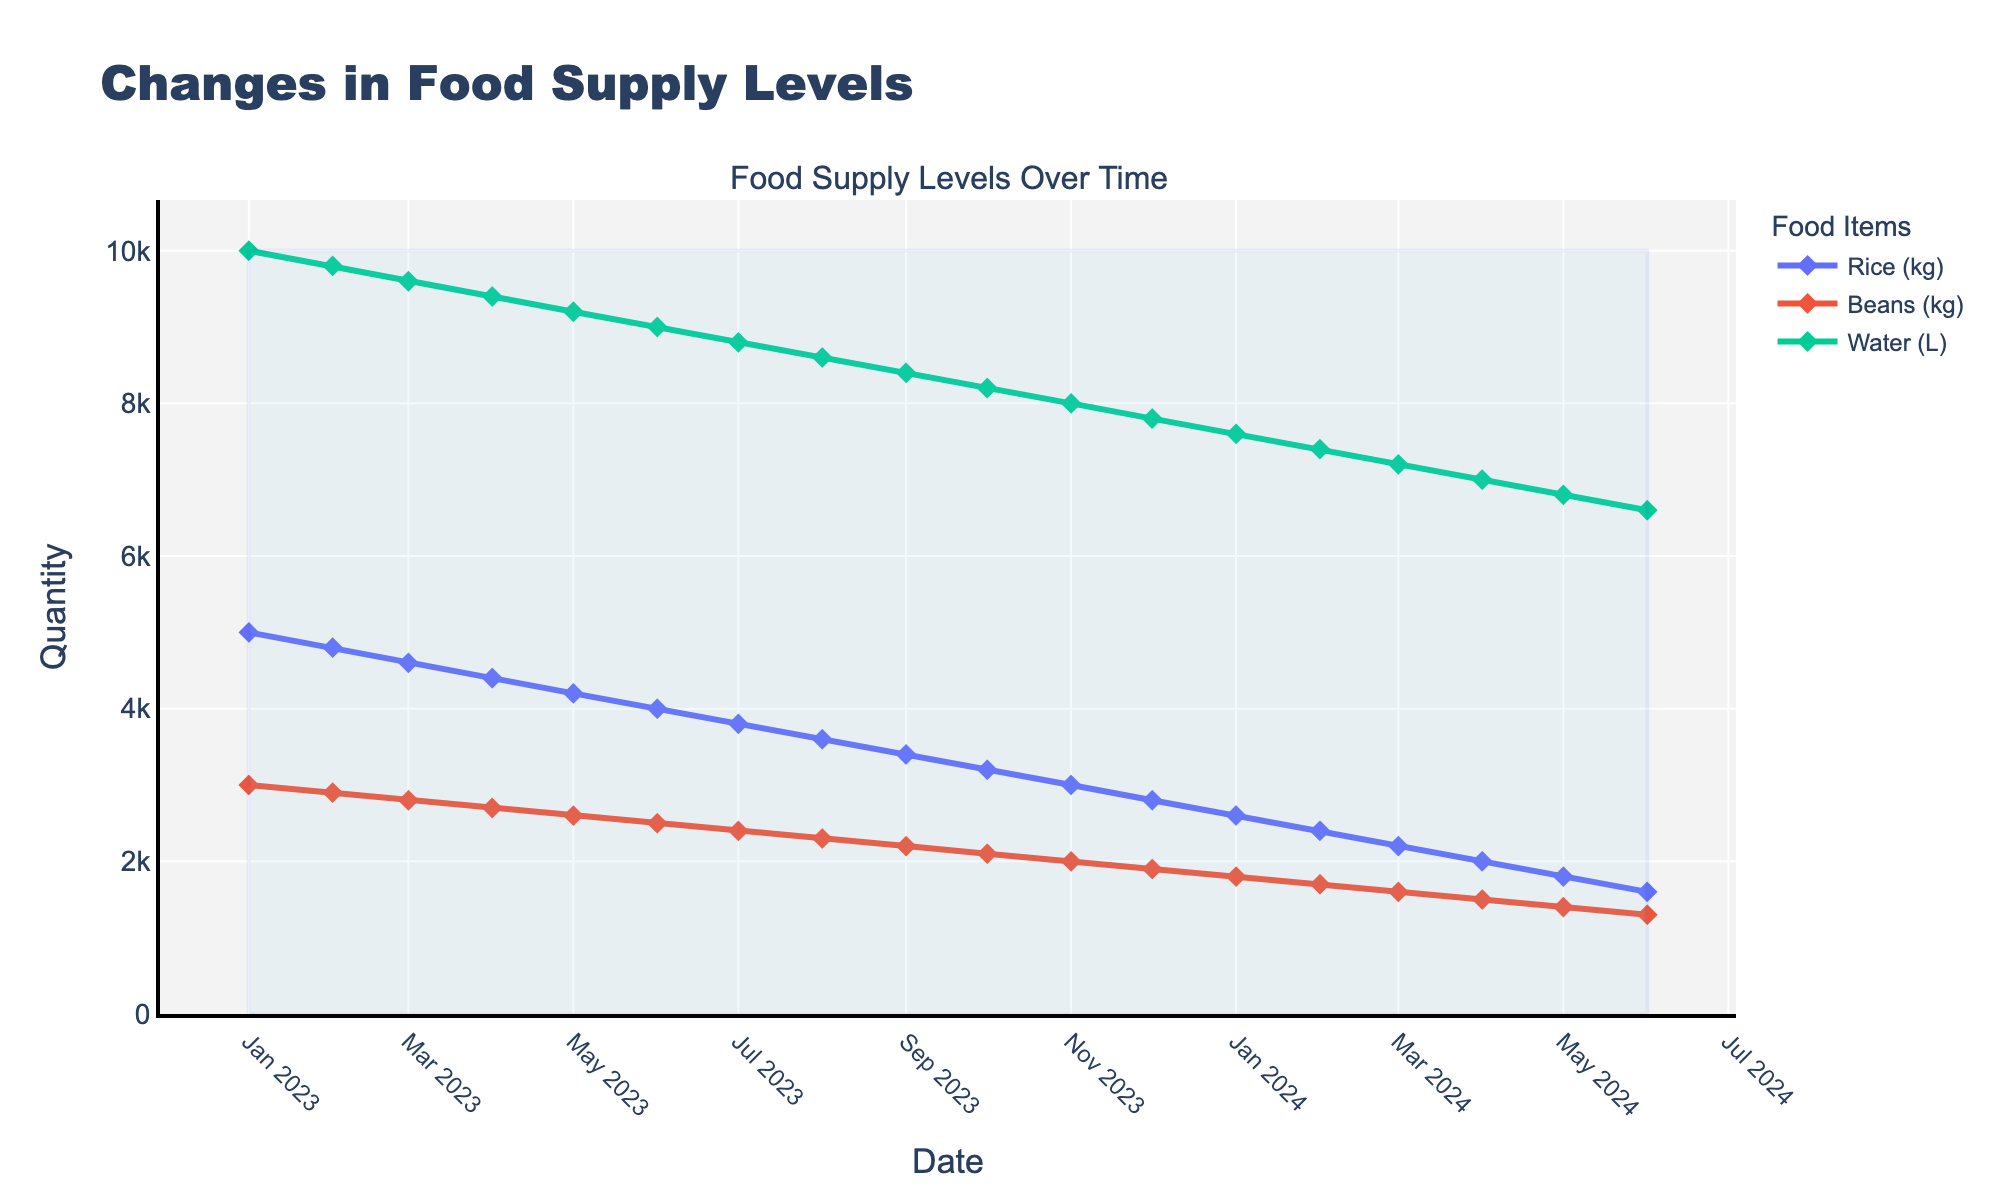what's the overall trend in the rice supply levels from January 2023 to June 2024? The rice supply levels decrease steadily over time. By observing the line representing rice, we see a consistent downward slope from the start to the end of the given timeframe.
Answer: Decreasing trend Which food item had the steepest decline from January 2023 to June 2024? By comparing the slopes of the lines, the line representing rice shows the steepest decline, indicating the fastest reduction in supply levels.
Answer: Rice What were the food supply levels for beans and water in December 2023? By locating December 2023 on the x-axis and observing the lines for beans and water, bean levels were at 1900 kg and water levels were at 7800 L.
Answer: Beans: 1900 kg, Water: 7800 L By how much did the water supply decrease from January 2023 to June 2024? Start at January 2023 (10000 L) and end at June 2024 (6600 L), then subtract June 2024 levels from January 2023 levels: 10000 L - 6600 L = 3400 L.
Answer: 3400 L Which month saw the food supply levels for rice fall below 4000 kg? By tracing the line for rice, it fell below 4000 kg in June 2023.
Answer: June 2023 What is the combined quantity of rice, beans, and water in October 2024? Sum the quantities for each item in October 2024: 3200 kg (rice) + 2100 kg (beans) + 8200 L (water) = 13500.
Answer: 13500 How does the average monthly decrease in rice supply compare to the average monthly decrease in beans supply? Calculate the change for rice and beans over the period (5000 kg to 1600 kg for rice, 3000 kg to 1300 kg for beans). The monthly decrease is (5000-1600)/17 ≈ 200 kg for rice and (3000-1300)/17 ≈ 100 kg for beans. Rice has a larger average monthly decrease.
Answer: Rice decreases more Is there any month where the supply of beans remains constant? Follow the line for beans and observe that it consistently decreases over time without any flat segments indicating constancy.
Answer: No What relationship between supply levels of rice and beans can be inferred from the chart? The supply levels of both rice and beans decrease over time, following similar downward trends, indicating a parallel relationship in their decreasing patterns on a monthly basis.
Answer: Parallel decreasing 